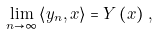Convert formula to latex. <formula><loc_0><loc_0><loc_500><loc_500>\lim _ { n \rightarrow \infty } \left \langle y _ { n } , x \right \rangle = Y \left ( x \right ) \, ,</formula> 